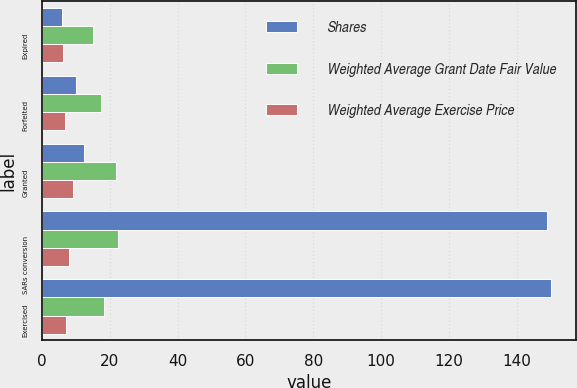Convert chart. <chart><loc_0><loc_0><loc_500><loc_500><stacked_bar_chart><ecel><fcel>Expired<fcel>Forfeited<fcel>Granted<fcel>SARs conversion<fcel>Exercised<nl><fcel>Shares<fcel>6<fcel>10<fcel>12.485<fcel>149<fcel>150<nl><fcel>Weighted Average Grant Date Fair Value<fcel>14.97<fcel>17.49<fcel>22<fcel>22.35<fcel>18.33<nl><fcel>Weighted Average Exercise Price<fcel>6.27<fcel>6.81<fcel>9.21<fcel>8.08<fcel>7.24<nl></chart> 